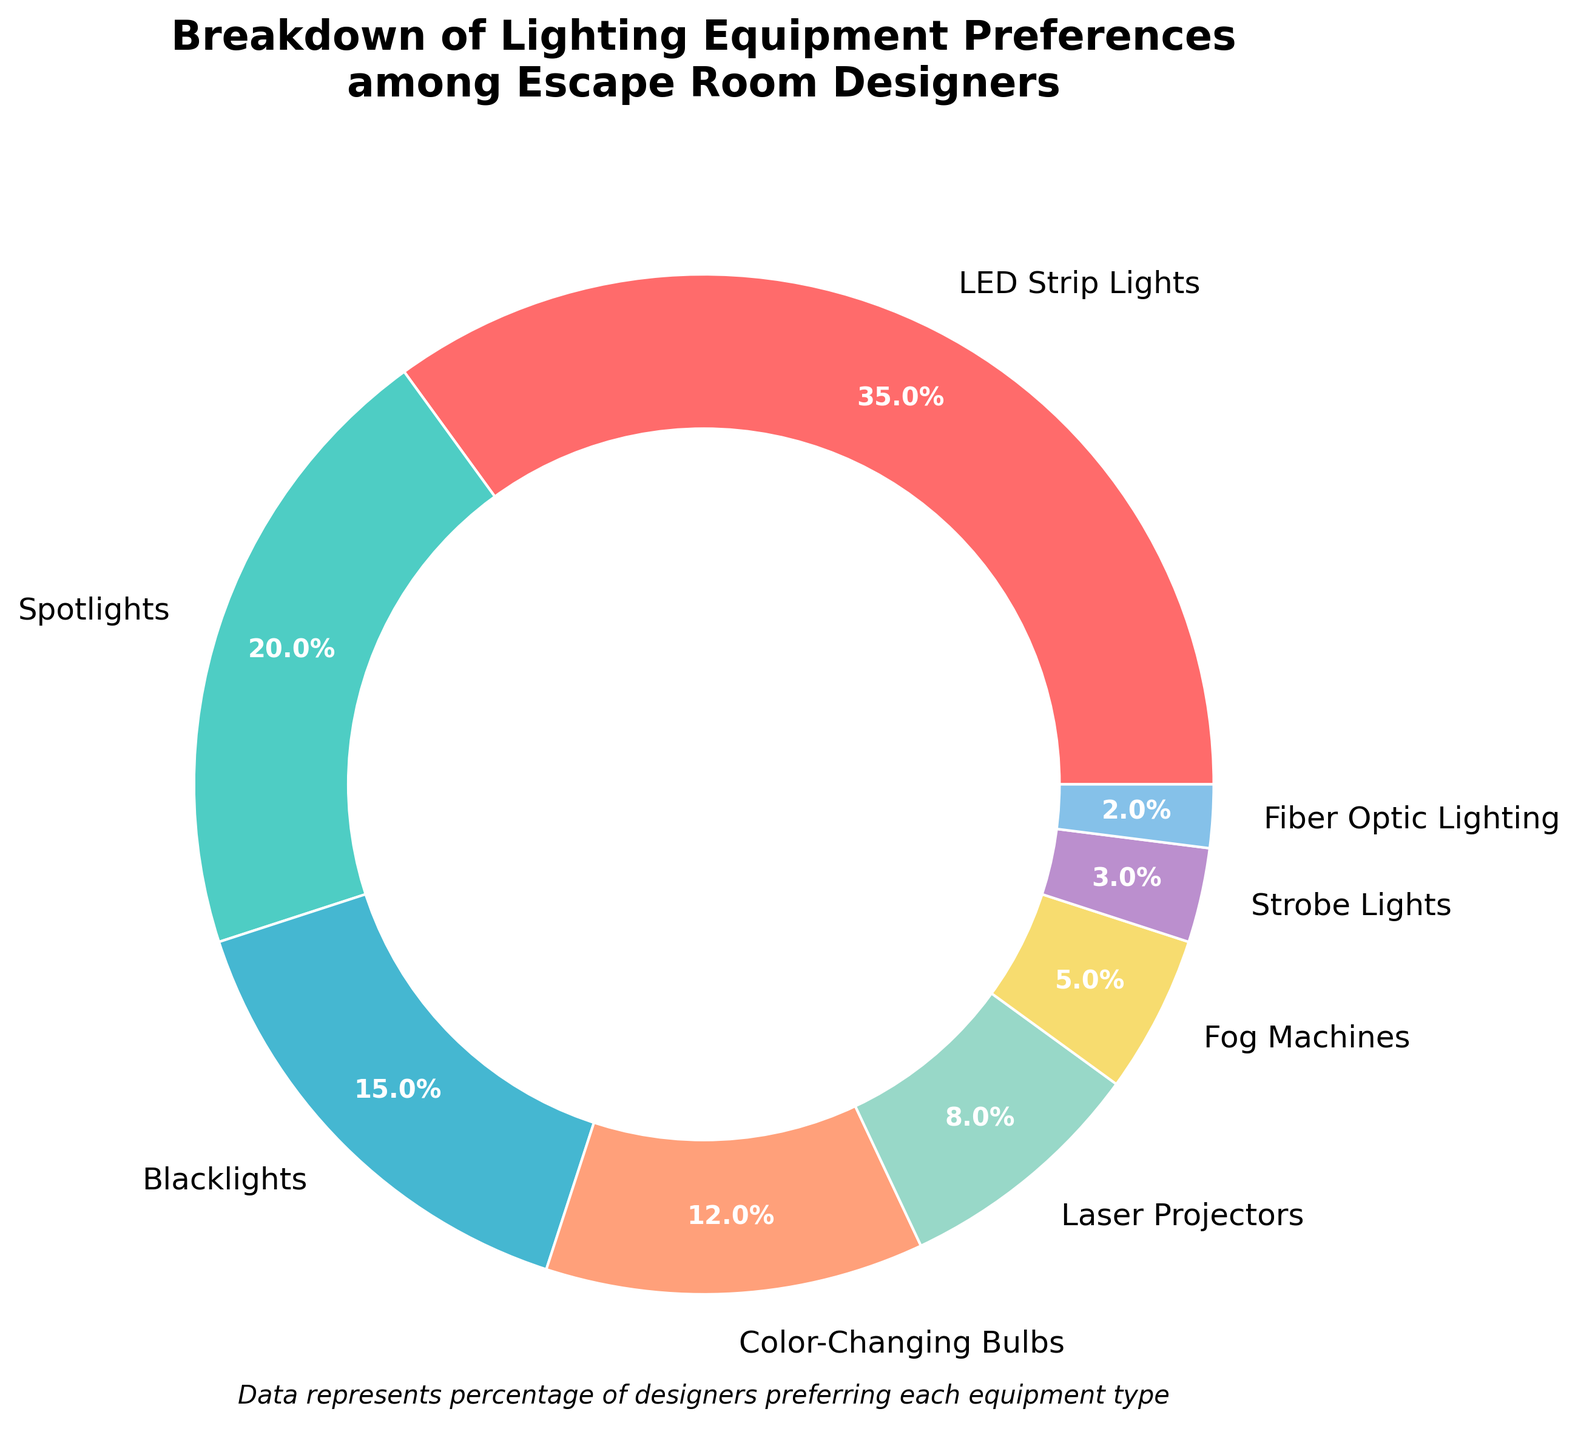What percentage of escape room designers prefer LED Strip Lights? The pie chart shows that LED Strip Lights are preferred by 35% of escape room designers. You can directly see this in the pie section labeled "LED Strip Lights" with the percentage annotated.
Answer: 35% Which equipment is preferred by a smaller percentage of designers: Fog Machines or Strobe Lights? From the pie chart, Fog Machines are preferred by 5% of designers, while Strobe Lights are preferred by 3%. So, Strobe Lights are preferred by a smaller percentage.
Answer: Strobe Lights How much more popular are Spotlights than Laser Projectors among escape room designers? Spotlights are preferred by 20% of designers and Laser Projectors by 8%. The difference in popularity is 20% - 8% = 12%.
Answer: 12% What is the combined percentage for Color-Changing Bulbs and Fiber Optic Lighting? Color-Changing Bulbs are preferred by 12% and Fiber Optic Lighting by 2%. Adding these percentages together: 12% + 2% = 14%.
Answer: 14% Which piece of equipment is the least preferred by escape room designers? The pie chart shows Fiber Optic Lighting as the least preferred with only 2% of designers selecting it.
Answer: Fiber Optic Lighting Which color represents Blacklights? The pie chart uses different colors to represent the segments. Blacklights are represented by a dark shade of green.
Answer: dark green Are Color-Changing Bulbs preferred more than Blacklights? If yes, by how much? Color-Changing Bulbs are preferred by 12% of designers, while Blacklights are preferred by 15%. Therefore, Color-Changing Bulbs are not preferred more than Blacklights.
Answer: No What is the average percentage of preference for Fog Machines, Strobe Lights, and Fiber Optic Lighting? Add the percentages of Fog Machines (5%), Strobe Lights (3%), and Fiber Optic Lighting (2%) and then divide by 3: (5% + 3% + 2%) / 3 = 10% / 3 = ~3.33%.
Answer: ~3.3% If we combine the popularity of LED Strip Lights, Spotlights, and Laser Projectors, what percentage of the total does this represent? Adding the percentages: LED Strip Lights (35%), Spotlights (20%), and Laser Projectors (8%) gives us 35% + 20% + 8% = 63%.
Answer: 63% Which equipment has a higher preference: the combination of Blacklights and Fog Machines or Color-Changing Bulbs alone? Blacklights are preferred by 15% and Fog Machines by 5%, combining for 20%. Color-Changing Bulbs have a 12% preference. Therefore, Blacklights and Fog Machines combined have a higher preference than Color-Changing Bulbs alone.
Answer: Blacklights and Fog Machines 